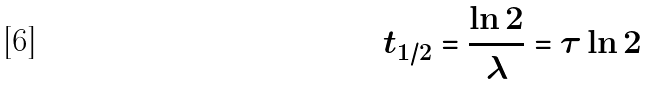<formula> <loc_0><loc_0><loc_500><loc_500>t _ { 1 / 2 } = \frac { \ln 2 } { \lambda } = \tau \ln 2</formula> 